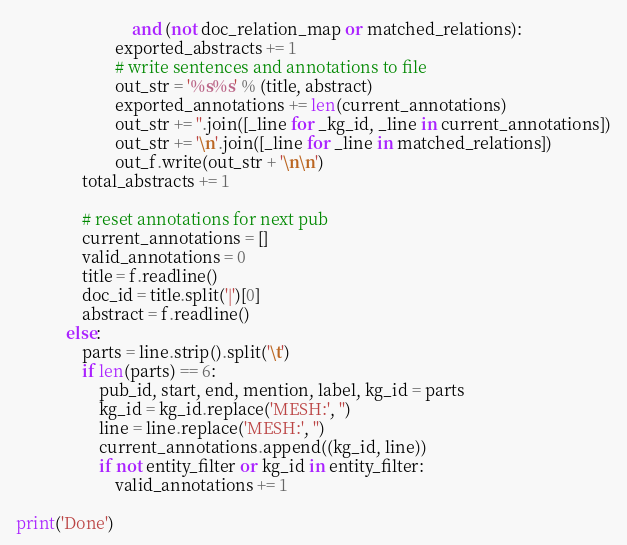<code> <loc_0><loc_0><loc_500><loc_500><_Python_>                            and (not doc_relation_map or matched_relations):
                        exported_abstracts += 1
                        # write sentences and annotations to file
                        out_str = '%s%s' % (title, abstract)
                        exported_annotations += len(current_annotations)
                        out_str += ''.join([_line for _kg_id, _line in current_annotations])
                        out_str += '\n'.join([_line for _line in matched_relations])
                        out_f.write(out_str + '\n\n')
                total_abstracts += 1

                # reset annotations for next pub
                current_annotations = []
                valid_annotations = 0
                title = f.readline()
                doc_id = title.split('|')[0]
                abstract = f.readline()
            else:
                parts = line.strip().split('\t')
                if len(parts) == 6:
                    pub_id, start, end, mention, label, kg_id = parts
                    kg_id = kg_id.replace('MESH:', '')
                    line = line.replace('MESH:', '')
                    current_annotations.append((kg_id, line))
                    if not entity_filter or kg_id in entity_filter:
                        valid_annotations += 1

print('Done')</code> 